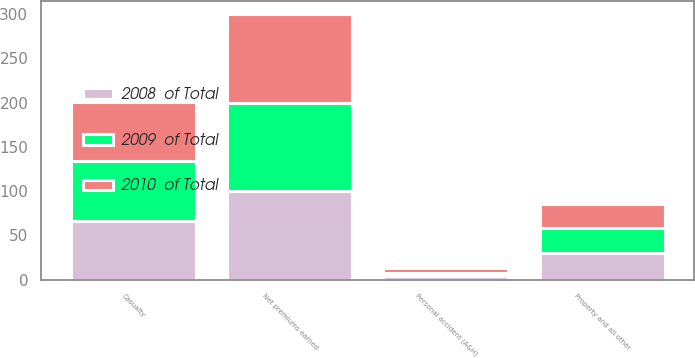Convert chart. <chart><loc_0><loc_0><loc_500><loc_500><stacked_bar_chart><ecel><fcel>Property and all other<fcel>Casualty<fcel>Personal accident (A&H)<fcel>Net premiums earned<nl><fcel>2010  of Total<fcel>28<fcel>67<fcel>5<fcel>100<nl><fcel>2008  of Total<fcel>30<fcel>66<fcel>4<fcel>100<nl><fcel>2009  of Total<fcel>28<fcel>68<fcel>4<fcel>100<nl></chart> 